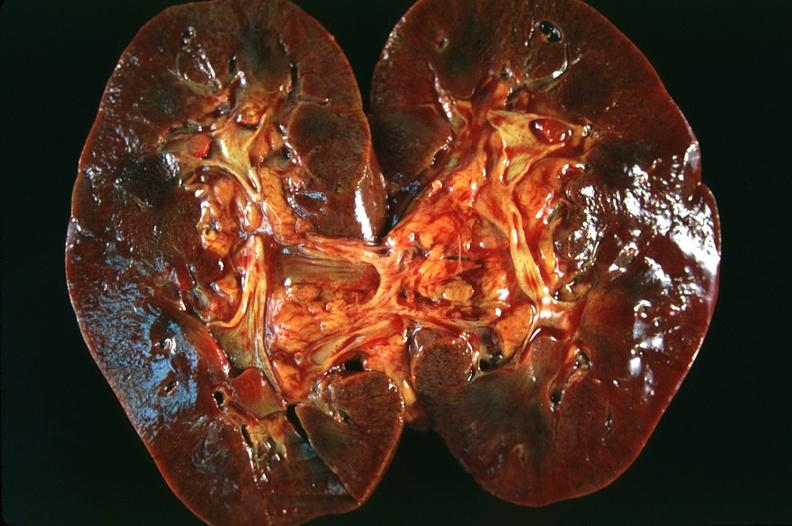what does this image show?
Answer the question using a single word or phrase. Kidney 